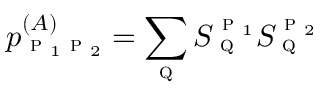<formula> <loc_0><loc_0><loc_500><loc_500>p _ { p _ { 1 } p _ { 2 } } ^ { ( A ) } = \sum _ { q } S _ { q } ^ { p _ { 1 } } S _ { q } ^ { p _ { 2 } }</formula> 